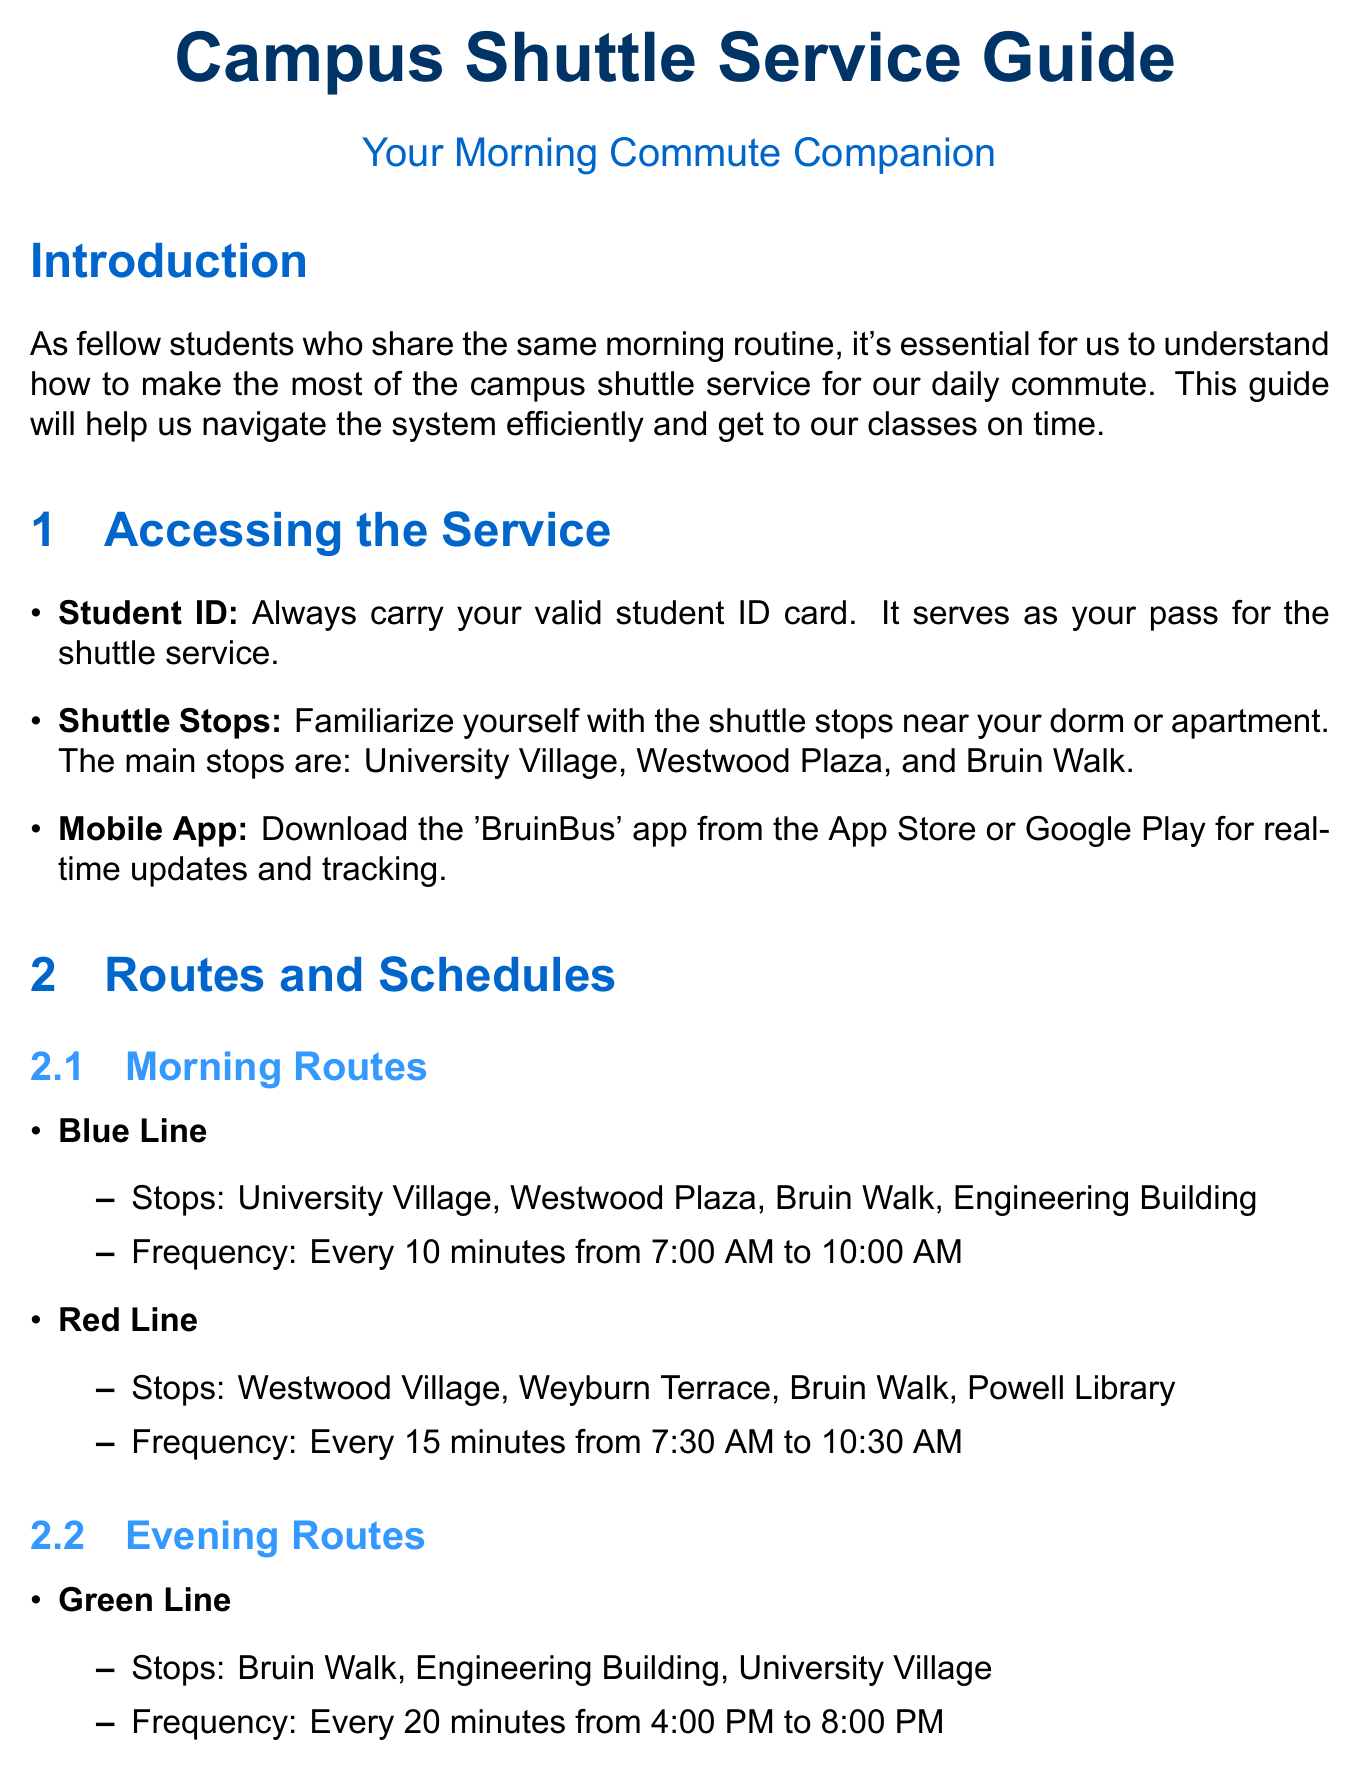What is the main purpose of the guide? The guide aims to help fellow students understand how to make the most of the campus shuttle service for their daily commute.
Answer: To assist students with the shuttle service What is the name of the mobile app for real-time tracking? The document mentions that the mobile app to download for real-time updates and tracking is named 'BruinBus'.
Answer: BruinBus How frequently does the Blue Line run in the morning? The Blue Line operates every 10 minutes from 7:00 AM to 10:00 AM, as stated in the document.
Answer: Every 10 minutes What should students do if they forgot something on the shuttle? Students can claim items left on the shuttle at the Transportation Office in Parking Structure 8, as indicated in the contact information section.
Answer: Transportation Office in Parking Structure 8 What time frame is considered peak time for the shuttle service? The document specifies that peak times for a more comfortable ride should be avoided from 8:30 AM to 9:15 AM.
Answer: 8:30 AM - 9:15 AM How many morning routes are listed in the document? Two morning routes are detailed in the document: the Blue Line and the Red Line.
Answer: Two Are wheelchair ramps available on all shuttles? The document confirms that all shuttles are equipped with wheelchair ramps and designated spaces for accessibility.
Answer: Yes What contact number is provided for the shuttle office? The shuttle office contact number is provided as 310-825-7433 in the document.
Answer: 310-825-7433 What is required to board the shuttle quickly? Students are advised to have their student ID ready for quick boarding as mentioned under tips for morning commute.
Answer: Student ID 